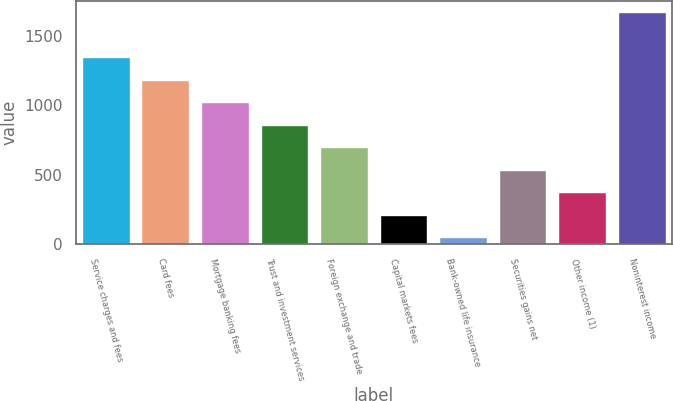Convert chart to OTSL. <chart><loc_0><loc_0><loc_500><loc_500><bar_chart><fcel>Service charges and fees<fcel>Card fees<fcel>Mortgage banking fees<fcel>Trust and investment services<fcel>Foreign exchange and trade<fcel>Capital markets fees<fcel>Bank-owned life insurance<fcel>Securities gains net<fcel>Other income (1)<fcel>Noninterest income<nl><fcel>1343.8<fcel>1182.2<fcel>1020.6<fcel>859<fcel>697.4<fcel>212.6<fcel>51<fcel>535.8<fcel>374.2<fcel>1667<nl></chart> 